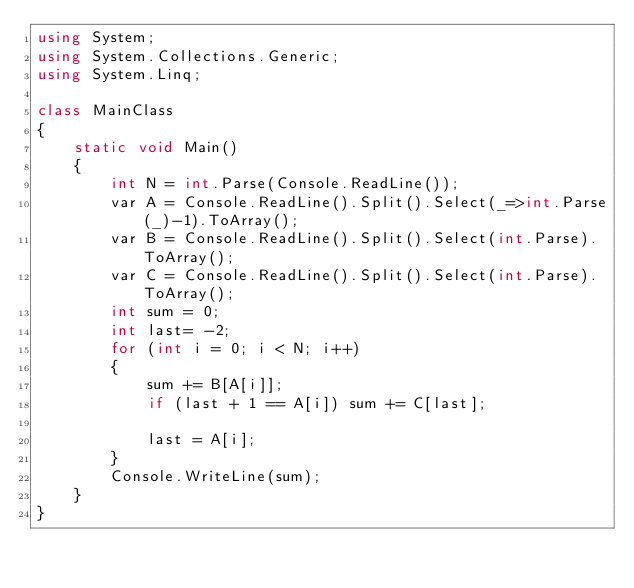Convert code to text. <code><loc_0><loc_0><loc_500><loc_500><_C#_>using System;
using System.Collections.Generic;
using System.Linq;

class MainClass
{
    static void Main()
    {
        int N = int.Parse(Console.ReadLine());
        var A = Console.ReadLine().Split().Select(_=>int.Parse(_)-1).ToArray();
        var B = Console.ReadLine().Split().Select(int.Parse).ToArray();
        var C = Console.ReadLine().Split().Select(int.Parse).ToArray();
        int sum = 0;
        int last= -2;
        for (int i = 0; i < N; i++)
        {
            sum += B[A[i]];
            if (last + 1 == A[i]) sum += C[last];

            last = A[i];
        }
        Console.WriteLine(sum);
    }
}</code> 